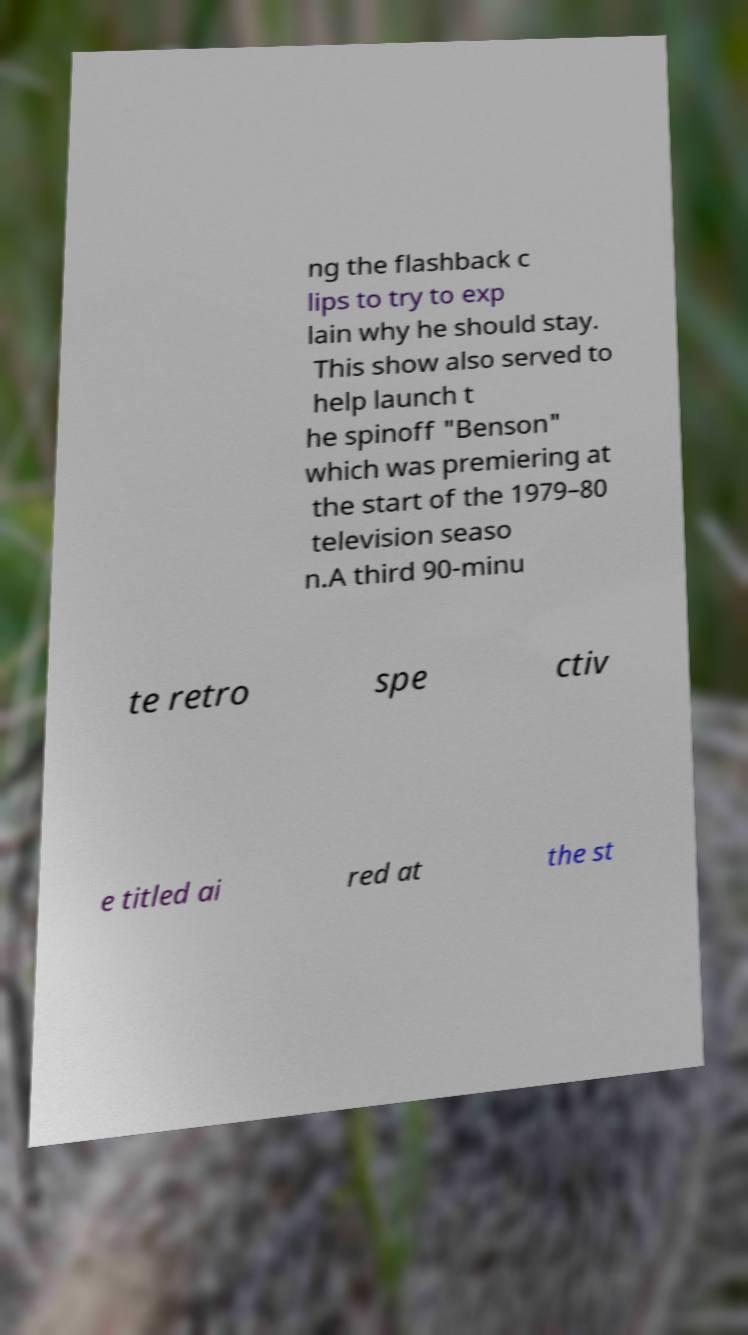I need the written content from this picture converted into text. Can you do that? ng the flashback c lips to try to exp lain why he should stay. This show also served to help launch t he spinoff "Benson" which was premiering at the start of the 1979–80 television seaso n.A third 90-minu te retro spe ctiv e titled ai red at the st 